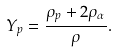<formula> <loc_0><loc_0><loc_500><loc_500>Y _ { p } = \frac { \rho _ { p } + 2 \rho _ { \alpha } } { \rho } .</formula> 